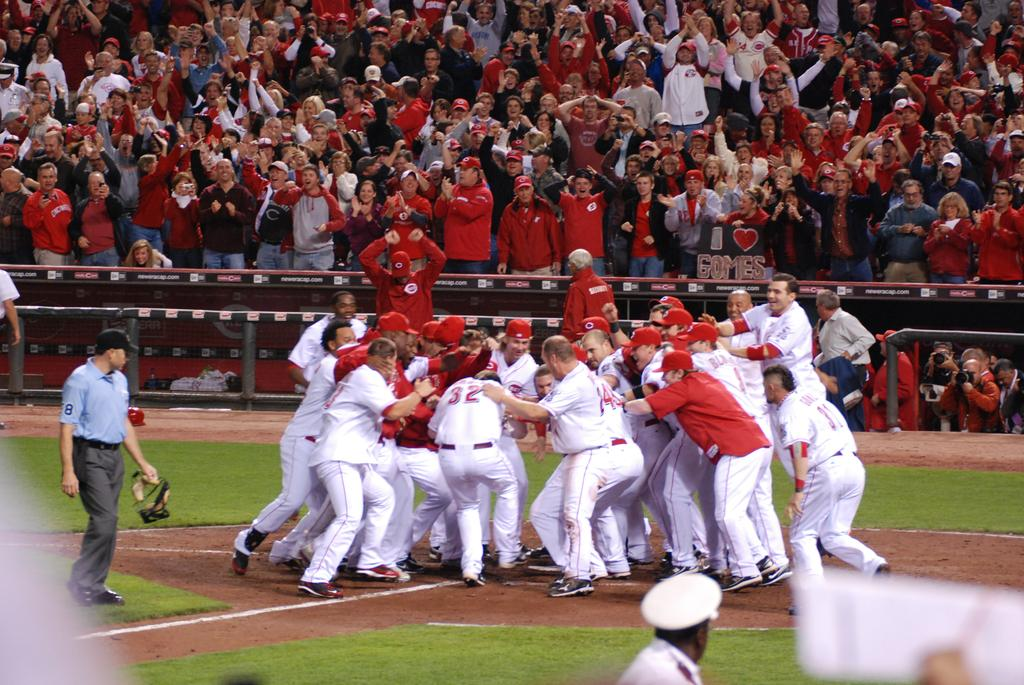<image>
Write a terse but informative summary of the picture. a group of ball players celebrating and one with the number 32 on 